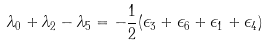<formula> <loc_0><loc_0><loc_500><loc_500>\lambda _ { 0 } + \lambda _ { 2 } - \lambda _ { 5 } = - \frac { 1 } { 2 } ( \epsilon _ { 3 } + \epsilon _ { 6 } + \epsilon _ { 1 } + \epsilon _ { 4 } )</formula> 